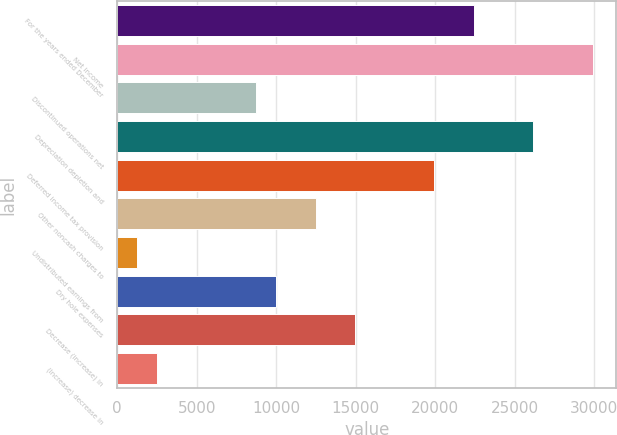<chart> <loc_0><loc_0><loc_500><loc_500><bar_chart><fcel>For the years ended December<fcel>Net income<fcel>Discontinued operations net<fcel>Depreciation depletion and<fcel>Deferred income tax provision<fcel>Other noncash charges to<fcel>Undistributed earnings from<fcel>Dry hole expenses<fcel>Decrease (increase) in<fcel>(Increase) decrease in<nl><fcel>22431.4<fcel>29900.2<fcel>8738.6<fcel>26165.8<fcel>19941.8<fcel>12473<fcel>1269.8<fcel>9983.4<fcel>14962.6<fcel>2514.6<nl></chart> 